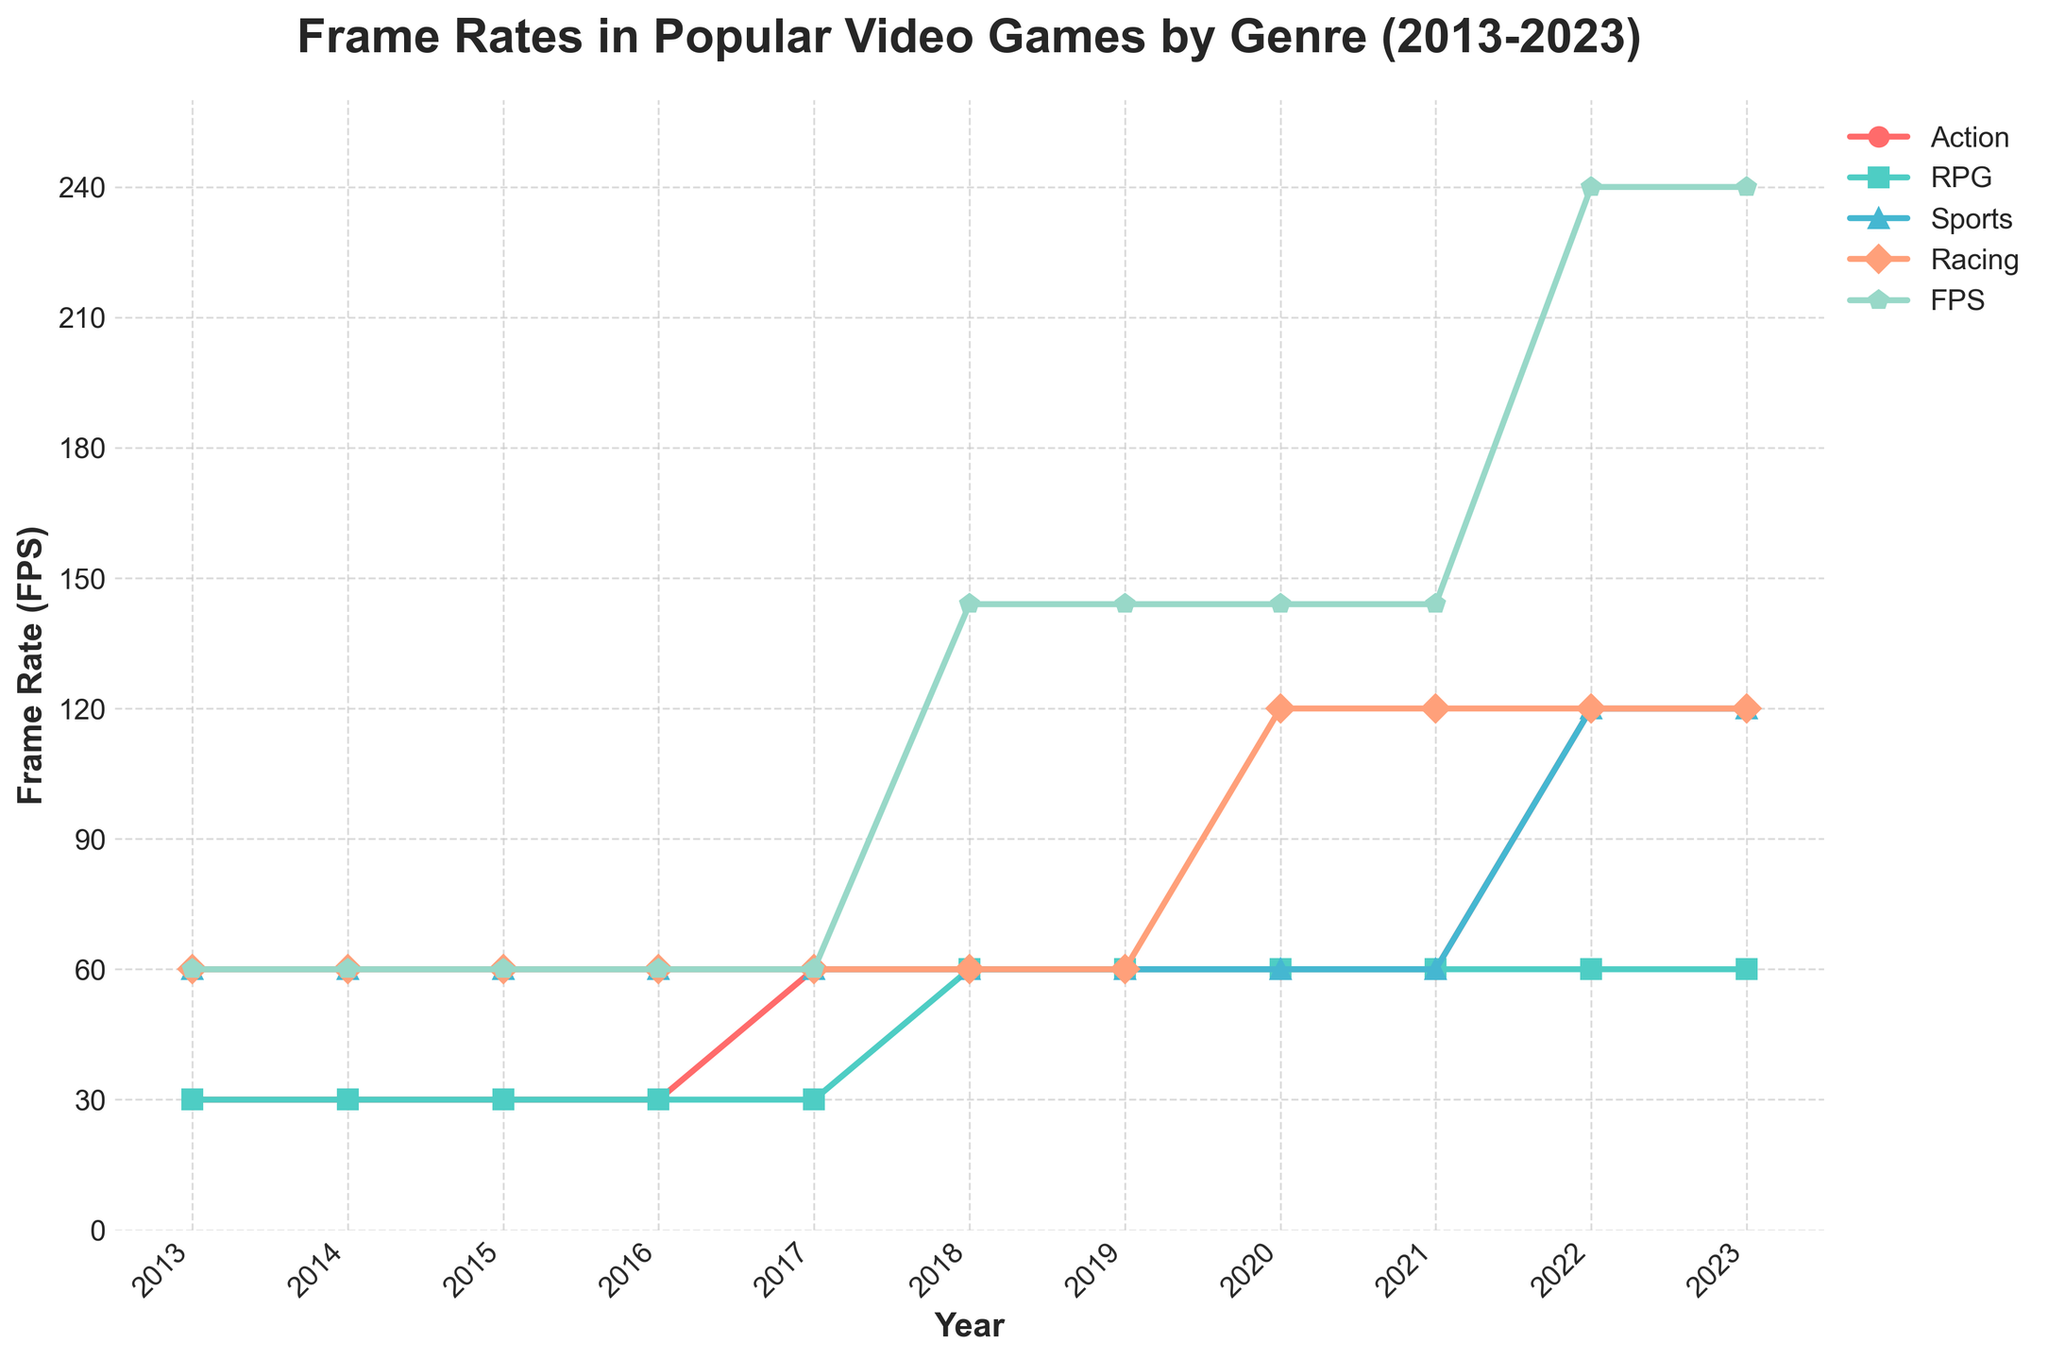How has the frame rate for Action games changed from 2013 to 2023? From 2013 to 2016, the frame rate for Action games remained at 30 FPS. In 2017, it increased to 60 FPS and remained at 60 FPS until 2021. In 2022, the frame rate increased to 120 FPS and stayed at 120 FPS in 2023.
Answer: Increased from 30 to 120 FPS Which genre saw the highest frame rate increase over the decade? By calculating the frame rate difference from 2013 to 2023 for each genre: Action (120 - 30 = 90 FPS increase), RPG (60 - 30 = 30 FPS increase), Sports (120 - 60 = 60 FPS increase), Racing (120 - 60 = 60 FPS increase), FPS (240 - 60 = 180 FPS increase). FPS saw the highest increase.
Answer: FPS What is the average frame rate for RPG games across the given years? Summing up the frame rates for RPG games from 2013 to 2023 (30 + 30 + 30 + 30 + 30 + 60 + 60 + 60 + 60 + 60 + 60 = 510) and dividing by the number of years (11), the average frame rate is 510/11.
Answer: 46.36 FPS Which years did the frame rate for Racing games show any changes? Observing the Racing genre's data: from 2013 to 2017 it was stable at 60 FPS. In 2020, it increased to 120 FPS and remained at 120 FPS till 2023.
Answer: 2020 In which year did the frame rates for FPS games first reach more than double that of RPG games? In 2018, the frame rate for FPS games was 144 FPS while RPG games had 60 FPS, which is more than double the frame rate of RPG games.
Answer: 2018 What was the largest drop or rise in frame rates within a year for any genre? Identifying the biggest yearly changes: Action increased from 30 to 60 FPS in 2017 (+30) and from 60 to 120 FPS in 2022 (+60). RPG increased from 30 to 60 FPS in 2018 (+30). Sports increased from 60 to 120 FPS in 2022 (+60). Racing didn't change drastically. FPS increased from 60 to 144 FPS in 2018 (+84) and from 144 to 240 FPS in 2022 (+96). The largest increase is for FPS in 2022 with a +96 FPS change.
Answer: FPS in 2022 Which genre maintained a consistent frame rate throughout the entire period? Checking each genre for stability: Action changed, RPG had changes, Sports had a change, Racing had changes. None of the genres maintained a completely consistent frame rate over the decade.
Answer: None How did the frame rate for Sports games compare to Action games in 2022? In 2022, Sports games had a frame rate of 120 FPS and Action games had a frame rate of 120 FPS.
Answer: Equal What is the overall trend for frame rates in FPS games from 2013 to 2023? FPS games started at 60 FPS in 2013, remained so till 2017, then increased to 144 FPS in 2018, and further increased to 240 FPS in 2022.
Answer: Increasing In 2020, which genre had the second-highest frame rate? For 2020, the frame rates for each genre were: Action (60 FPS), RPG (60 FPS), Sports (60 FPS), Racing (120 FPS), FPS (144 FPS). The second-highest frame rate was for Racing games.
Answer: Racing 